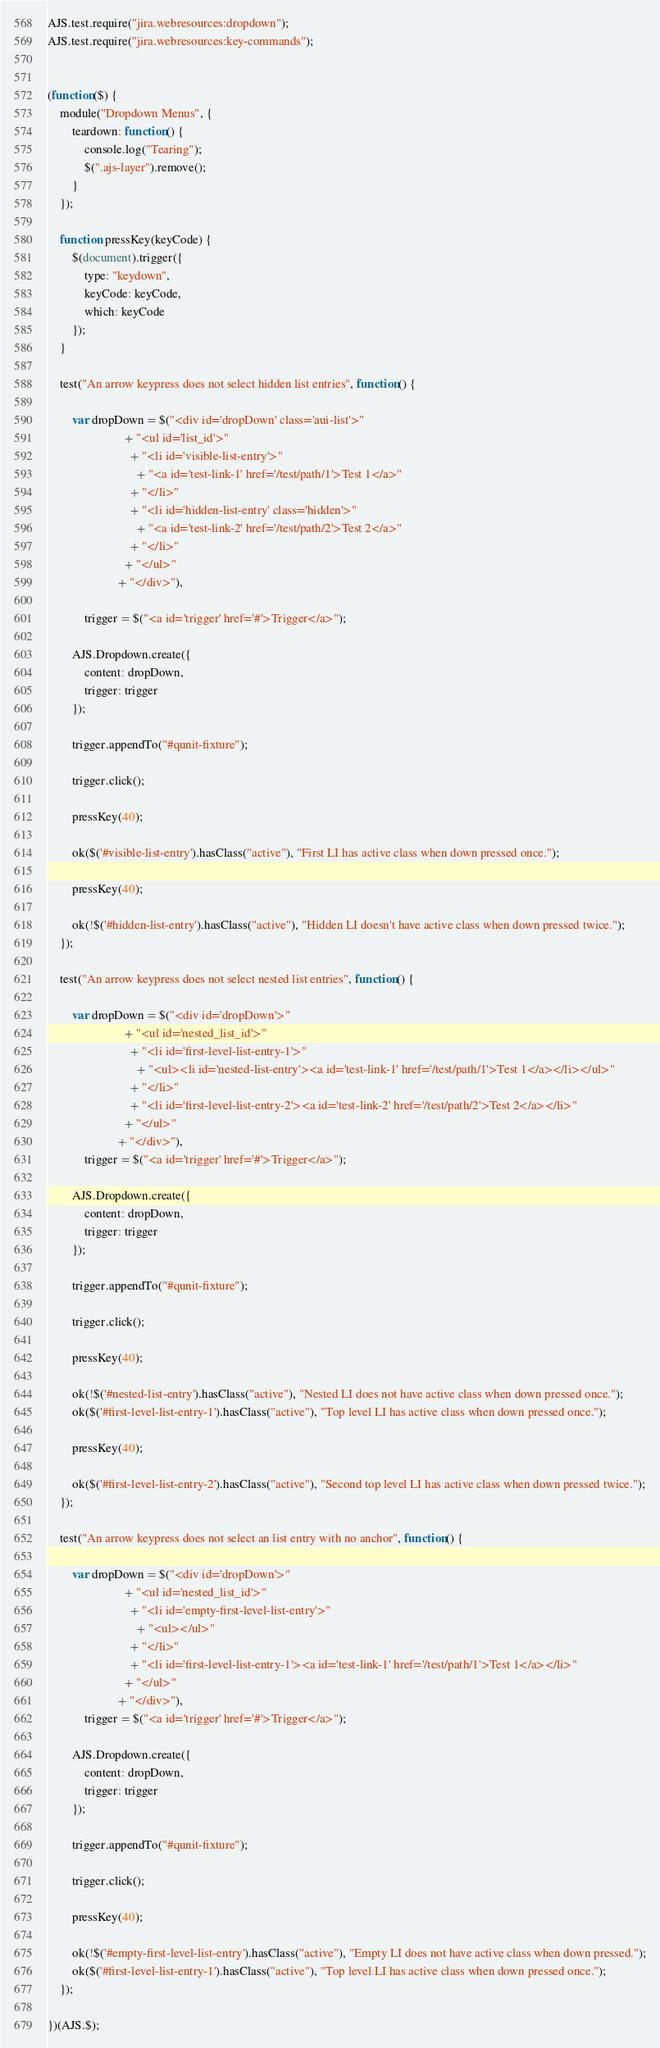<code> <loc_0><loc_0><loc_500><loc_500><_JavaScript_>AJS.test.require("jira.webresources:dropdown");
AJS.test.require("jira.webresources:key-commands");


(function($) {
    module("Dropdown Menus", {
        teardown: function() {
            console.log("Tearing");
            $(".ajs-layer").remove();
        }
    });

    function pressKey(keyCode) {
        $(document).trigger({
            type: "keydown",
            keyCode: keyCode,
            which: keyCode
        });
    }

    test("An arrow keypress does not select hidden list entries", function() {

        var dropDown = $("<div id='dropDown' class='aui-list'>"
                         + "<ul id='list_id'>"
                           + "<li id='visible-list-entry'>"
                             + "<a id='test-link-1' href='/test/path/1'>Test 1</a>"
                           + "</li>"
                           + "<li id='hidden-list-entry' class='hidden'>"
                             + "<a id='test-link-2' href='/test/path/2'>Test 2</a>"
                           + "</li>"
                         + "</ul>"
                       + "</div>"),

            trigger = $("<a id='trigger' href='#'>Trigger</a>");

        AJS.Dropdown.create({
            content: dropDown,
            trigger: trigger
        });

        trigger.appendTo("#qunit-fixture");

        trigger.click();

        pressKey(40);

        ok($('#visible-list-entry').hasClass("active"), "First LI has active class when down pressed once.");

        pressKey(40);

        ok(!$('#hidden-list-entry').hasClass("active"), "Hidden LI doesn't have active class when down pressed twice.");
    });

    test("An arrow keypress does not select nested list entries", function() {

        var dropDown = $("<div id='dropDown'>"
                         + "<ul id='nested_list_id'>"
                           + "<li id='first-level-list-entry-1'>"
                             + "<ul><li id='nested-list-entry'><a id='test-link-1' href='/test/path/1'>Test 1</a></li></ul>"
                           + "</li>"
                           + "<li id='first-level-list-entry-2'><a id='test-link-2' href='/test/path/2'>Test 2</a></li>"
                         + "</ul>"
                       + "</div>"),
            trigger = $("<a id='trigger' href='#'>Trigger</a>");

        AJS.Dropdown.create({
            content: dropDown,
            trigger: trigger
        });

        trigger.appendTo("#qunit-fixture");

        trigger.click();

        pressKey(40);

        ok(!$('#nested-list-entry').hasClass("active"), "Nested LI does not have active class when down pressed once.");
        ok($('#first-level-list-entry-1').hasClass("active"), "Top level LI has active class when down pressed once.");

        pressKey(40);

        ok($('#first-level-list-entry-2').hasClass("active"), "Second top level LI has active class when down pressed twice.");
    });

    test("An arrow keypress does not select an list entry with no anchor", function() {

        var dropDown = $("<div id='dropDown'>"
                         + "<ul id='nested_list_id'>"
                           + "<li id='empty-first-level-list-entry'>"
                             + "<ul></ul>"
                           + "</li>"
                           + "<li id='first-level-list-entry-1'><a id='test-link-1' href='/test/path/1'>Test 1</a></li>"
                         + "</ul>"
                       + "</div>"),
            trigger = $("<a id='trigger' href='#'>Trigger</a>");

        AJS.Dropdown.create({
            content: dropDown,
            trigger: trigger
        });

        trigger.appendTo("#qunit-fixture");

        trigger.click();

        pressKey(40);

        ok(!$('#empty-first-level-list-entry').hasClass("active"), "Empty LI does not have active class when down pressed.");
        ok($('#first-level-list-entry-1').hasClass("active"), "Top level LI has active class when down pressed once.");
    });

})(AJS.$);
</code> 